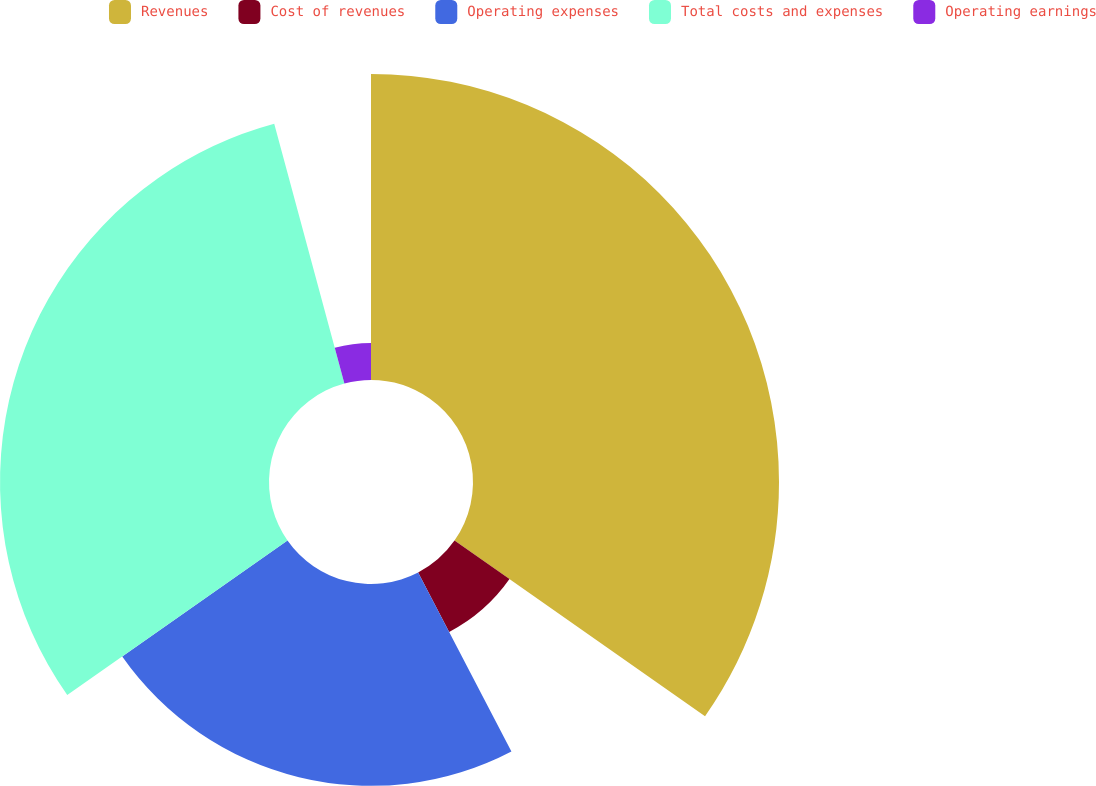Convert chart. <chart><loc_0><loc_0><loc_500><loc_500><pie_chart><fcel>Revenues<fcel>Cost of revenues<fcel>Operating expenses<fcel>Total costs and expenses<fcel>Operating earnings<nl><fcel>34.73%<fcel>7.62%<fcel>22.91%<fcel>30.53%<fcel>4.2%<nl></chart> 